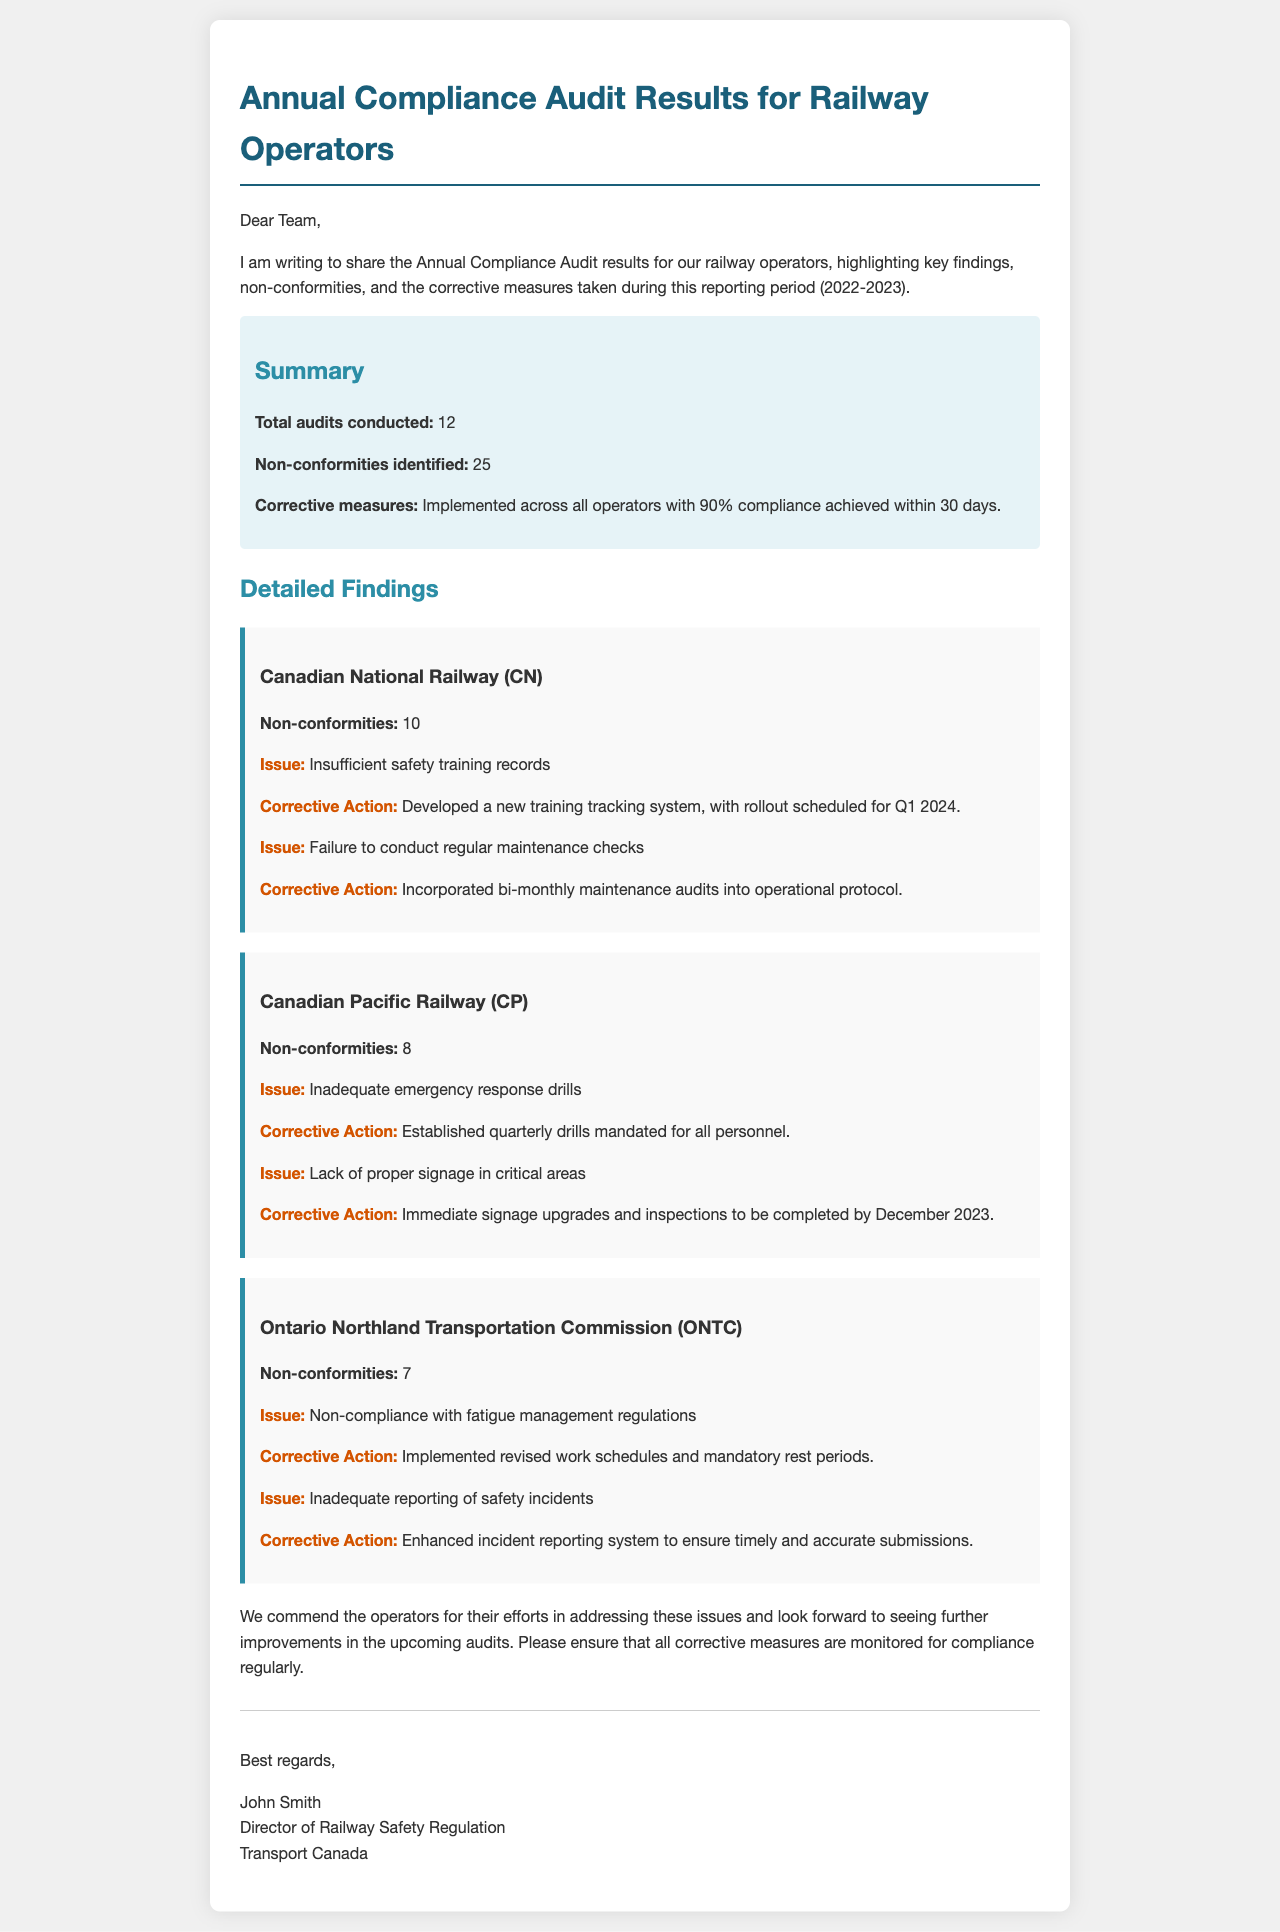what is the total number of audits conducted? The total number of audits is specified in the summary section of the document.
Answer: 12 how many non-conformities were identified? The summary section lists the total non-conformities identified during the audits.
Answer: 25 which railway operator had the highest number of non-conformities? The non-conformities for each operator are detailed, indicating which has the most.
Answer: Canadian National Railway (CN) what is the corrective action planned for insufficient safety training records? The corrective action for this issue is mentioned under the relevant operator's findings.
Answer: Developed a new training tracking system, with rollout scheduled for Q1 2024 by when are the signage upgrades for CP expected to be completed? The deadline for the signage upgrades for Canadian Pacific Railway is stated in the document.
Answer: December 2023 what corrective action was taken by ONTC for fatigue management issues? The action taken by ONTC is outlined in the section for that operator.
Answer: Implemented revised work schedules and mandatory rest periods how many non-conformities did Ontario Northland Transportation Commission have? The number of non-conformities for each operator is specified in their respective sections.
Answer: 7 who is the director of railway safety regulation? The signature block at the bottom of the document lists the director's name and title.
Answer: John Smith 